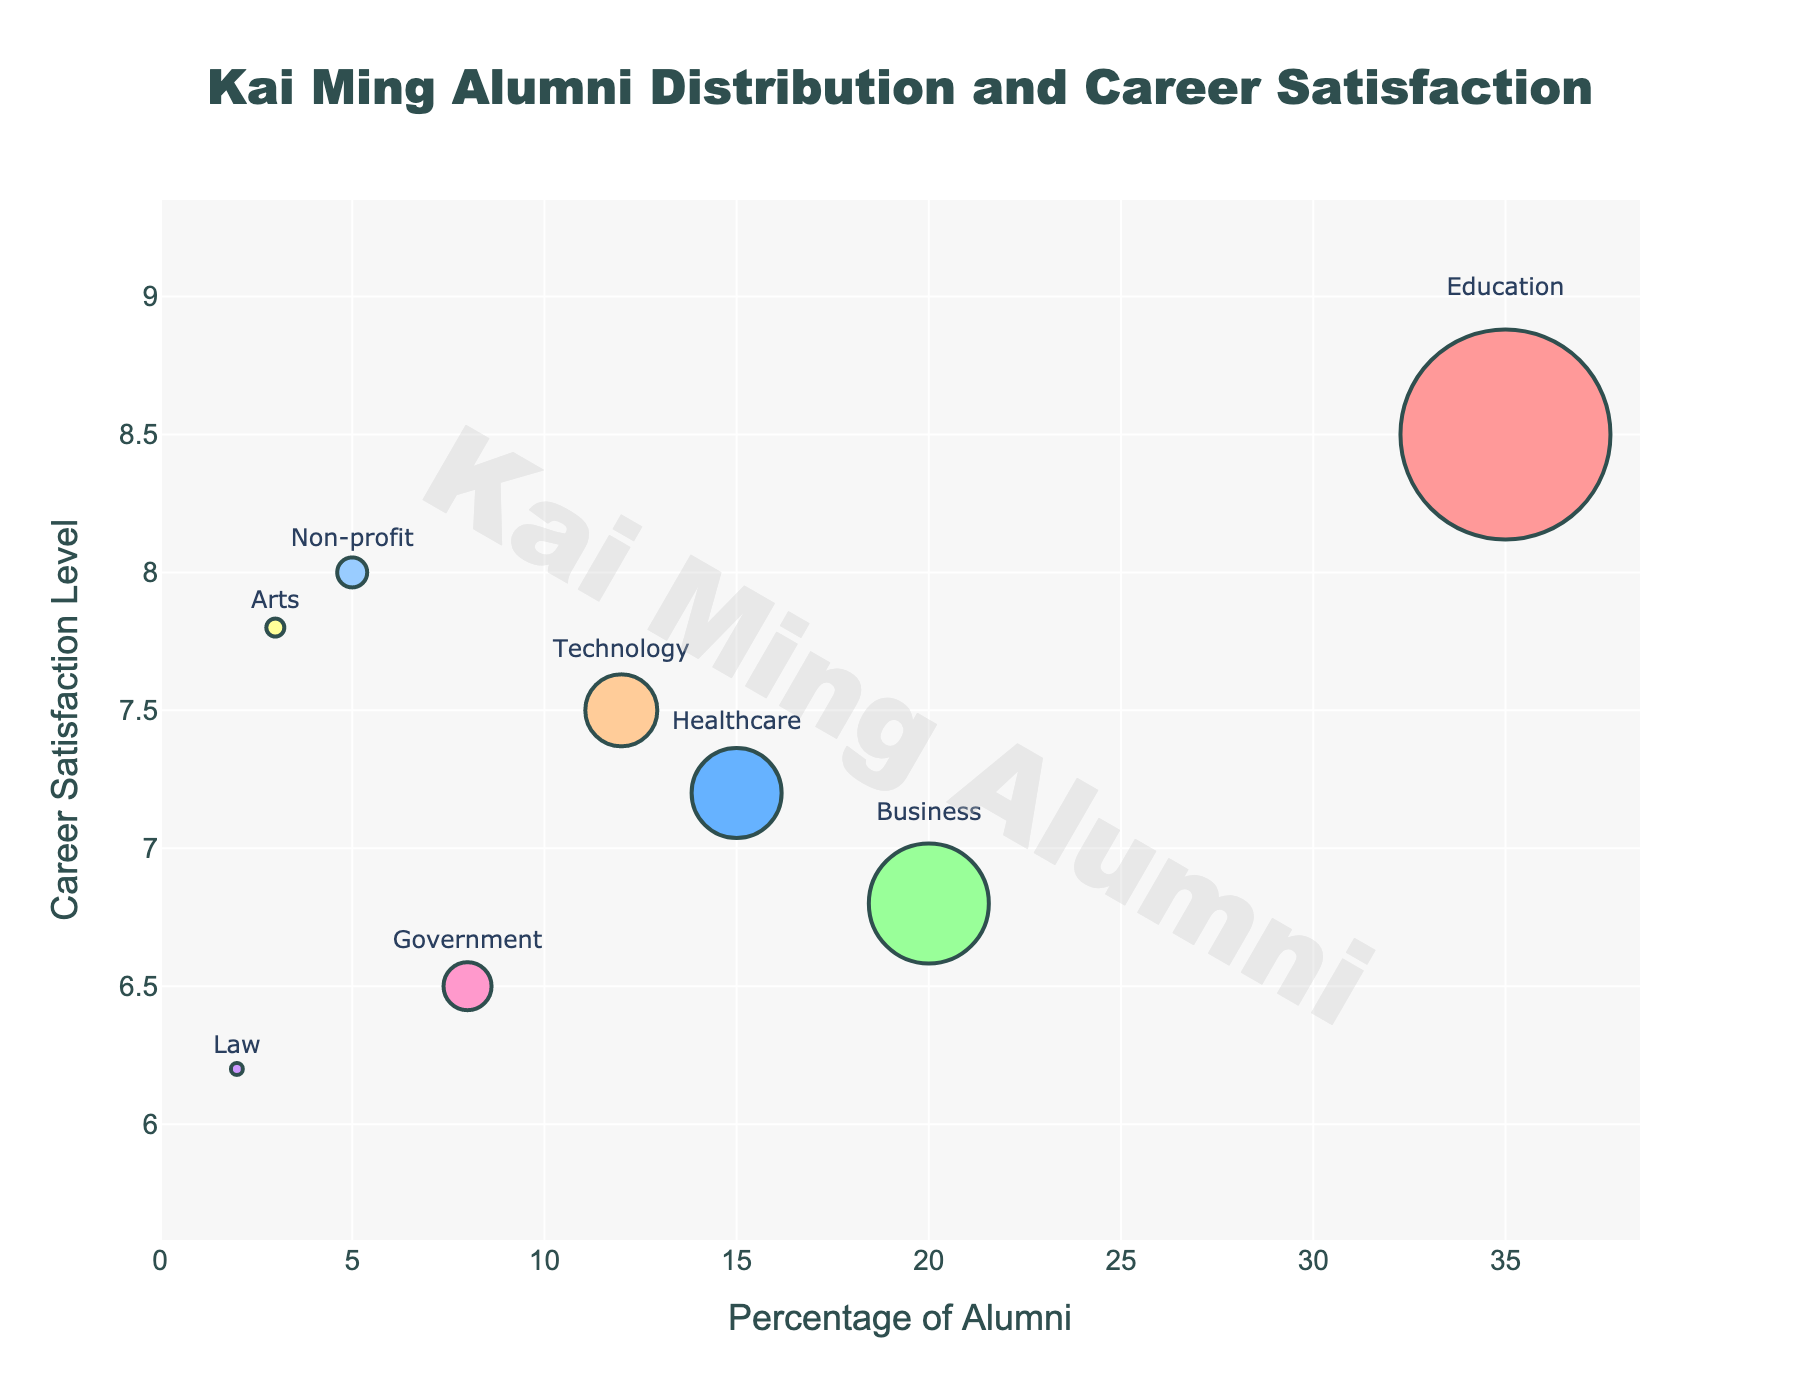What's the title of the plot? The title is clearly displayed at the top of the figure in a larger font size and distinctive color. The exact wording should be directly extracted from the title.
Answer: Kai Ming Alumni Distribution and Career Satisfaction What is the percentage of Kai Ming alumni in the Business profession? Locate the bubble labeled "Business" and read the percentage value from the hovertext or bubble text.
Answer: 20% Which profession has the highest career satisfaction level? Compare the y-axis values of all the bubbles. The profession with the highest y-axis value represents the highest satisfaction level.
Answer: Education How many professions have a career satisfaction level above 7.0? Count the number of bubbles where the y-axis value (career satisfaction) is greater than 7.0.
Answer: 5 Which profession shows the lowest percentage of alumni and what is its career satisfaction level? Identify the smallest bubble, which represents the lowest percentage, and read its hovertext for both percentage and career satisfaction level.
Answer: Law, 6.2 What is the total percentage of alumni in the Education and Technology professions? Add the percentages of the Education and Technology bubbles. Education is 35%, and Technology is 12%. Sum these values.
Answer: 47% How do career satisfaction levels of Non-profit compare to Healthcare? Compare the y-axis values of the Non-profit and Healthcare bubbles.
Answer: Non-profit has a higher career satisfaction level (8.0 vs. 7.2) Which professions have a satisfaction level below 7.0, and what are their respective percentages? Identify the bubbles below the 7.0 mark on the y-axis and list their percentages from the hovertext.
Answer: Business (20%), Government (8%), Law (2%) What is the difference in satisfaction levels between Education and Business professions? Subtract the career satisfaction level of Business from Education. Education is 8.5, and Business is 6.8. The difference is 8.5 - 6.8.
Answer: 1.7 If we average the satisfaction levels of Healthcare, Technology, and Non-profit, what is the result? Sum the satisfaction levels of Healthcare (7.2), Technology (7.5), and Non-profit (8.0), and then divide by 3. (7.2 + 7.5 + 8.0) / 3.
Answer: 7.57 